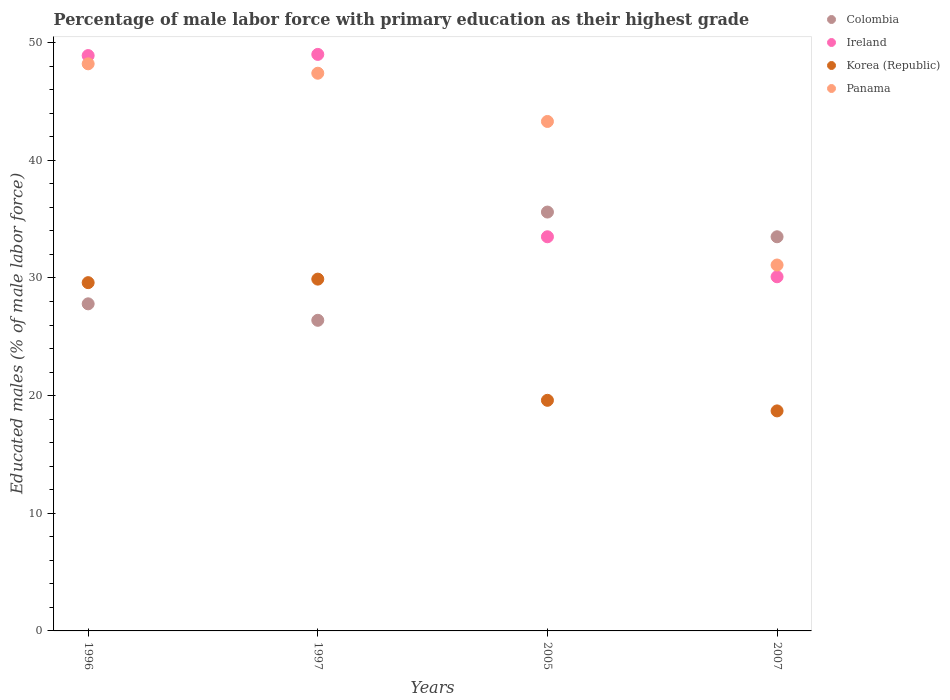How many different coloured dotlines are there?
Your answer should be compact. 4. Is the number of dotlines equal to the number of legend labels?
Give a very brief answer. Yes. What is the percentage of male labor force with primary education in Panama in 2007?
Offer a very short reply. 31.1. Across all years, what is the minimum percentage of male labor force with primary education in Colombia?
Offer a terse response. 26.4. In which year was the percentage of male labor force with primary education in Korea (Republic) maximum?
Keep it short and to the point. 1997. In which year was the percentage of male labor force with primary education in Korea (Republic) minimum?
Your answer should be very brief. 2007. What is the total percentage of male labor force with primary education in Colombia in the graph?
Provide a succinct answer. 123.3. What is the difference between the percentage of male labor force with primary education in Colombia in 1996 and that in 1997?
Ensure brevity in your answer.  1.4. What is the difference between the percentage of male labor force with primary education in Korea (Republic) in 2005 and the percentage of male labor force with primary education in Panama in 2007?
Give a very brief answer. -11.5. What is the average percentage of male labor force with primary education in Colombia per year?
Make the answer very short. 30.82. In the year 1996, what is the difference between the percentage of male labor force with primary education in Korea (Republic) and percentage of male labor force with primary education in Ireland?
Your answer should be compact. -19.3. What is the ratio of the percentage of male labor force with primary education in Ireland in 1996 to that in 2007?
Your answer should be very brief. 1.62. Is the percentage of male labor force with primary education in Korea (Republic) in 1996 less than that in 1997?
Provide a short and direct response. Yes. Is the difference between the percentage of male labor force with primary education in Korea (Republic) in 2005 and 2007 greater than the difference between the percentage of male labor force with primary education in Ireland in 2005 and 2007?
Ensure brevity in your answer.  No. What is the difference between the highest and the second highest percentage of male labor force with primary education in Colombia?
Give a very brief answer. 2.1. What is the difference between the highest and the lowest percentage of male labor force with primary education in Colombia?
Make the answer very short. 9.2. In how many years, is the percentage of male labor force with primary education in Korea (Republic) greater than the average percentage of male labor force with primary education in Korea (Republic) taken over all years?
Your answer should be very brief. 2. Is the sum of the percentage of male labor force with primary education in Panama in 1996 and 1997 greater than the maximum percentage of male labor force with primary education in Korea (Republic) across all years?
Give a very brief answer. Yes. Is it the case that in every year, the sum of the percentage of male labor force with primary education in Ireland and percentage of male labor force with primary education in Panama  is greater than the sum of percentage of male labor force with primary education in Colombia and percentage of male labor force with primary education in Korea (Republic)?
Keep it short and to the point. No. What is the difference between two consecutive major ticks on the Y-axis?
Give a very brief answer. 10. Are the values on the major ticks of Y-axis written in scientific E-notation?
Ensure brevity in your answer.  No. Does the graph contain any zero values?
Offer a very short reply. No. Does the graph contain grids?
Make the answer very short. No. Where does the legend appear in the graph?
Your answer should be compact. Top right. How many legend labels are there?
Keep it short and to the point. 4. How are the legend labels stacked?
Offer a very short reply. Vertical. What is the title of the graph?
Provide a succinct answer. Percentage of male labor force with primary education as their highest grade. What is the label or title of the Y-axis?
Provide a short and direct response. Educated males (% of male labor force). What is the Educated males (% of male labor force) in Colombia in 1996?
Provide a succinct answer. 27.8. What is the Educated males (% of male labor force) in Ireland in 1996?
Provide a succinct answer. 48.9. What is the Educated males (% of male labor force) in Korea (Republic) in 1996?
Offer a terse response. 29.6. What is the Educated males (% of male labor force) of Panama in 1996?
Offer a terse response. 48.2. What is the Educated males (% of male labor force) of Colombia in 1997?
Ensure brevity in your answer.  26.4. What is the Educated males (% of male labor force) of Korea (Republic) in 1997?
Make the answer very short. 29.9. What is the Educated males (% of male labor force) of Panama in 1997?
Provide a short and direct response. 47.4. What is the Educated males (% of male labor force) of Colombia in 2005?
Give a very brief answer. 35.6. What is the Educated males (% of male labor force) of Ireland in 2005?
Offer a very short reply. 33.5. What is the Educated males (% of male labor force) of Korea (Republic) in 2005?
Keep it short and to the point. 19.6. What is the Educated males (% of male labor force) of Panama in 2005?
Keep it short and to the point. 43.3. What is the Educated males (% of male labor force) in Colombia in 2007?
Provide a succinct answer. 33.5. What is the Educated males (% of male labor force) of Ireland in 2007?
Ensure brevity in your answer.  30.1. What is the Educated males (% of male labor force) of Korea (Republic) in 2007?
Your answer should be very brief. 18.7. What is the Educated males (% of male labor force) in Panama in 2007?
Your answer should be compact. 31.1. Across all years, what is the maximum Educated males (% of male labor force) in Colombia?
Your answer should be very brief. 35.6. Across all years, what is the maximum Educated males (% of male labor force) in Korea (Republic)?
Provide a succinct answer. 29.9. Across all years, what is the maximum Educated males (% of male labor force) of Panama?
Provide a short and direct response. 48.2. Across all years, what is the minimum Educated males (% of male labor force) in Colombia?
Keep it short and to the point. 26.4. Across all years, what is the minimum Educated males (% of male labor force) of Ireland?
Keep it short and to the point. 30.1. Across all years, what is the minimum Educated males (% of male labor force) of Korea (Republic)?
Your response must be concise. 18.7. Across all years, what is the minimum Educated males (% of male labor force) of Panama?
Make the answer very short. 31.1. What is the total Educated males (% of male labor force) in Colombia in the graph?
Your response must be concise. 123.3. What is the total Educated males (% of male labor force) of Ireland in the graph?
Your answer should be compact. 161.5. What is the total Educated males (% of male labor force) of Korea (Republic) in the graph?
Provide a short and direct response. 97.8. What is the total Educated males (% of male labor force) of Panama in the graph?
Keep it short and to the point. 170. What is the difference between the Educated males (% of male labor force) of Colombia in 1996 and that in 1997?
Make the answer very short. 1.4. What is the difference between the Educated males (% of male labor force) of Ireland in 1996 and that in 1997?
Keep it short and to the point. -0.1. What is the difference between the Educated males (% of male labor force) in Korea (Republic) in 1996 and that in 1997?
Ensure brevity in your answer.  -0.3. What is the difference between the Educated males (% of male labor force) in Panama in 1996 and that in 1997?
Your response must be concise. 0.8. What is the difference between the Educated males (% of male labor force) in Ireland in 1996 and that in 2005?
Offer a terse response. 15.4. What is the difference between the Educated males (% of male labor force) of Korea (Republic) in 1996 and that in 2005?
Give a very brief answer. 10. What is the difference between the Educated males (% of male labor force) of Panama in 1996 and that in 2005?
Offer a terse response. 4.9. What is the difference between the Educated males (% of male labor force) of Colombia in 1996 and that in 2007?
Offer a terse response. -5.7. What is the difference between the Educated males (% of male labor force) in Ireland in 1997 and that in 2005?
Provide a succinct answer. 15.5. What is the difference between the Educated males (% of male labor force) in Panama in 1997 and that in 2005?
Provide a succinct answer. 4.1. What is the difference between the Educated males (% of male labor force) of Colombia in 1997 and that in 2007?
Your answer should be very brief. -7.1. What is the difference between the Educated males (% of male labor force) in Ireland in 1997 and that in 2007?
Keep it short and to the point. 18.9. What is the difference between the Educated males (% of male labor force) of Colombia in 1996 and the Educated males (% of male labor force) of Ireland in 1997?
Offer a terse response. -21.2. What is the difference between the Educated males (% of male labor force) of Colombia in 1996 and the Educated males (% of male labor force) of Panama in 1997?
Your answer should be compact. -19.6. What is the difference between the Educated males (% of male labor force) of Ireland in 1996 and the Educated males (% of male labor force) of Korea (Republic) in 1997?
Make the answer very short. 19. What is the difference between the Educated males (% of male labor force) in Ireland in 1996 and the Educated males (% of male labor force) in Panama in 1997?
Give a very brief answer. 1.5. What is the difference between the Educated males (% of male labor force) of Korea (Republic) in 1996 and the Educated males (% of male labor force) of Panama in 1997?
Provide a short and direct response. -17.8. What is the difference between the Educated males (% of male labor force) of Colombia in 1996 and the Educated males (% of male labor force) of Ireland in 2005?
Make the answer very short. -5.7. What is the difference between the Educated males (% of male labor force) in Colombia in 1996 and the Educated males (% of male labor force) in Panama in 2005?
Ensure brevity in your answer.  -15.5. What is the difference between the Educated males (% of male labor force) of Ireland in 1996 and the Educated males (% of male labor force) of Korea (Republic) in 2005?
Make the answer very short. 29.3. What is the difference between the Educated males (% of male labor force) of Korea (Republic) in 1996 and the Educated males (% of male labor force) of Panama in 2005?
Give a very brief answer. -13.7. What is the difference between the Educated males (% of male labor force) in Colombia in 1996 and the Educated males (% of male labor force) in Ireland in 2007?
Offer a terse response. -2.3. What is the difference between the Educated males (% of male labor force) in Colombia in 1996 and the Educated males (% of male labor force) in Korea (Republic) in 2007?
Ensure brevity in your answer.  9.1. What is the difference between the Educated males (% of male labor force) in Ireland in 1996 and the Educated males (% of male labor force) in Korea (Republic) in 2007?
Make the answer very short. 30.2. What is the difference between the Educated males (% of male labor force) in Ireland in 1996 and the Educated males (% of male labor force) in Panama in 2007?
Your answer should be very brief. 17.8. What is the difference between the Educated males (% of male labor force) in Colombia in 1997 and the Educated males (% of male labor force) in Ireland in 2005?
Offer a terse response. -7.1. What is the difference between the Educated males (% of male labor force) of Colombia in 1997 and the Educated males (% of male labor force) of Korea (Republic) in 2005?
Offer a very short reply. 6.8. What is the difference between the Educated males (% of male labor force) of Colombia in 1997 and the Educated males (% of male labor force) of Panama in 2005?
Give a very brief answer. -16.9. What is the difference between the Educated males (% of male labor force) in Ireland in 1997 and the Educated males (% of male labor force) in Korea (Republic) in 2005?
Keep it short and to the point. 29.4. What is the difference between the Educated males (% of male labor force) of Ireland in 1997 and the Educated males (% of male labor force) of Korea (Republic) in 2007?
Provide a short and direct response. 30.3. What is the difference between the Educated males (% of male labor force) of Ireland in 1997 and the Educated males (% of male labor force) of Panama in 2007?
Give a very brief answer. 17.9. What is the difference between the Educated males (% of male labor force) in Korea (Republic) in 1997 and the Educated males (% of male labor force) in Panama in 2007?
Keep it short and to the point. -1.2. What is the difference between the Educated males (% of male labor force) of Colombia in 2005 and the Educated males (% of male labor force) of Korea (Republic) in 2007?
Your answer should be very brief. 16.9. What is the difference between the Educated males (% of male labor force) of Ireland in 2005 and the Educated males (% of male labor force) of Korea (Republic) in 2007?
Offer a terse response. 14.8. What is the difference between the Educated males (% of male labor force) of Ireland in 2005 and the Educated males (% of male labor force) of Panama in 2007?
Provide a succinct answer. 2.4. What is the difference between the Educated males (% of male labor force) of Korea (Republic) in 2005 and the Educated males (% of male labor force) of Panama in 2007?
Your answer should be very brief. -11.5. What is the average Educated males (% of male labor force) in Colombia per year?
Make the answer very short. 30.82. What is the average Educated males (% of male labor force) in Ireland per year?
Offer a very short reply. 40.38. What is the average Educated males (% of male labor force) of Korea (Republic) per year?
Keep it short and to the point. 24.45. What is the average Educated males (% of male labor force) of Panama per year?
Offer a very short reply. 42.5. In the year 1996, what is the difference between the Educated males (% of male labor force) in Colombia and Educated males (% of male labor force) in Ireland?
Provide a succinct answer. -21.1. In the year 1996, what is the difference between the Educated males (% of male labor force) in Colombia and Educated males (% of male labor force) in Panama?
Your response must be concise. -20.4. In the year 1996, what is the difference between the Educated males (% of male labor force) in Ireland and Educated males (% of male labor force) in Korea (Republic)?
Provide a succinct answer. 19.3. In the year 1996, what is the difference between the Educated males (% of male labor force) of Ireland and Educated males (% of male labor force) of Panama?
Keep it short and to the point. 0.7. In the year 1996, what is the difference between the Educated males (% of male labor force) in Korea (Republic) and Educated males (% of male labor force) in Panama?
Ensure brevity in your answer.  -18.6. In the year 1997, what is the difference between the Educated males (% of male labor force) of Colombia and Educated males (% of male labor force) of Ireland?
Offer a very short reply. -22.6. In the year 1997, what is the difference between the Educated males (% of male labor force) of Colombia and Educated males (% of male labor force) of Korea (Republic)?
Your response must be concise. -3.5. In the year 1997, what is the difference between the Educated males (% of male labor force) of Colombia and Educated males (% of male labor force) of Panama?
Provide a short and direct response. -21. In the year 1997, what is the difference between the Educated males (% of male labor force) in Ireland and Educated males (% of male labor force) in Panama?
Offer a terse response. 1.6. In the year 1997, what is the difference between the Educated males (% of male labor force) of Korea (Republic) and Educated males (% of male labor force) of Panama?
Ensure brevity in your answer.  -17.5. In the year 2005, what is the difference between the Educated males (% of male labor force) in Colombia and Educated males (% of male labor force) in Ireland?
Ensure brevity in your answer.  2.1. In the year 2005, what is the difference between the Educated males (% of male labor force) in Ireland and Educated males (% of male labor force) in Korea (Republic)?
Offer a very short reply. 13.9. In the year 2005, what is the difference between the Educated males (% of male labor force) in Ireland and Educated males (% of male labor force) in Panama?
Keep it short and to the point. -9.8. In the year 2005, what is the difference between the Educated males (% of male labor force) of Korea (Republic) and Educated males (% of male labor force) of Panama?
Keep it short and to the point. -23.7. In the year 2007, what is the difference between the Educated males (% of male labor force) in Colombia and Educated males (% of male labor force) in Ireland?
Make the answer very short. 3.4. In the year 2007, what is the difference between the Educated males (% of male labor force) of Colombia and Educated males (% of male labor force) of Panama?
Give a very brief answer. 2.4. In the year 2007, what is the difference between the Educated males (% of male labor force) in Ireland and Educated males (% of male labor force) in Panama?
Provide a short and direct response. -1. What is the ratio of the Educated males (% of male labor force) of Colombia in 1996 to that in 1997?
Your answer should be very brief. 1.05. What is the ratio of the Educated males (% of male labor force) in Ireland in 1996 to that in 1997?
Keep it short and to the point. 1. What is the ratio of the Educated males (% of male labor force) of Korea (Republic) in 1996 to that in 1997?
Keep it short and to the point. 0.99. What is the ratio of the Educated males (% of male labor force) of Panama in 1996 to that in 1997?
Give a very brief answer. 1.02. What is the ratio of the Educated males (% of male labor force) of Colombia in 1996 to that in 2005?
Provide a short and direct response. 0.78. What is the ratio of the Educated males (% of male labor force) of Ireland in 1996 to that in 2005?
Make the answer very short. 1.46. What is the ratio of the Educated males (% of male labor force) of Korea (Republic) in 1996 to that in 2005?
Keep it short and to the point. 1.51. What is the ratio of the Educated males (% of male labor force) of Panama in 1996 to that in 2005?
Your answer should be very brief. 1.11. What is the ratio of the Educated males (% of male labor force) in Colombia in 1996 to that in 2007?
Provide a short and direct response. 0.83. What is the ratio of the Educated males (% of male labor force) of Ireland in 1996 to that in 2007?
Your answer should be very brief. 1.62. What is the ratio of the Educated males (% of male labor force) of Korea (Republic) in 1996 to that in 2007?
Offer a terse response. 1.58. What is the ratio of the Educated males (% of male labor force) in Panama in 1996 to that in 2007?
Provide a succinct answer. 1.55. What is the ratio of the Educated males (% of male labor force) of Colombia in 1997 to that in 2005?
Offer a terse response. 0.74. What is the ratio of the Educated males (% of male labor force) in Ireland in 1997 to that in 2005?
Your answer should be compact. 1.46. What is the ratio of the Educated males (% of male labor force) in Korea (Republic) in 1997 to that in 2005?
Your answer should be very brief. 1.53. What is the ratio of the Educated males (% of male labor force) in Panama in 1997 to that in 2005?
Your response must be concise. 1.09. What is the ratio of the Educated males (% of male labor force) of Colombia in 1997 to that in 2007?
Provide a succinct answer. 0.79. What is the ratio of the Educated males (% of male labor force) in Ireland in 1997 to that in 2007?
Your response must be concise. 1.63. What is the ratio of the Educated males (% of male labor force) of Korea (Republic) in 1997 to that in 2007?
Your answer should be compact. 1.6. What is the ratio of the Educated males (% of male labor force) in Panama in 1997 to that in 2007?
Make the answer very short. 1.52. What is the ratio of the Educated males (% of male labor force) in Colombia in 2005 to that in 2007?
Give a very brief answer. 1.06. What is the ratio of the Educated males (% of male labor force) of Ireland in 2005 to that in 2007?
Provide a succinct answer. 1.11. What is the ratio of the Educated males (% of male labor force) of Korea (Republic) in 2005 to that in 2007?
Ensure brevity in your answer.  1.05. What is the ratio of the Educated males (% of male labor force) in Panama in 2005 to that in 2007?
Your answer should be very brief. 1.39. What is the difference between the highest and the second highest Educated males (% of male labor force) of Panama?
Ensure brevity in your answer.  0.8. What is the difference between the highest and the lowest Educated males (% of male labor force) of Colombia?
Keep it short and to the point. 9.2. What is the difference between the highest and the lowest Educated males (% of male labor force) of Ireland?
Provide a succinct answer. 18.9. What is the difference between the highest and the lowest Educated males (% of male labor force) in Panama?
Ensure brevity in your answer.  17.1. 